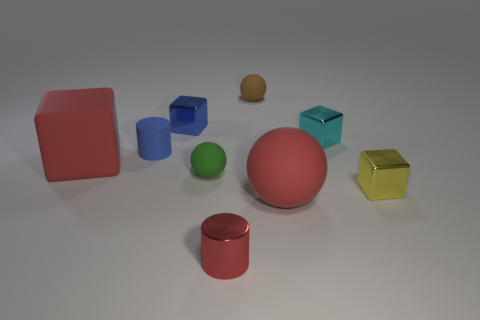Subtract all small blocks. How many blocks are left? 1 Subtract all blue blocks. How many blocks are left? 3 Add 1 tiny green rubber cubes. How many objects exist? 10 Subtract all balls. How many objects are left? 6 Subtract 3 cubes. How many cubes are left? 1 Subtract all brown rubber cylinders. Subtract all small matte cylinders. How many objects are left? 8 Add 8 blue objects. How many blue objects are left? 10 Add 9 large purple blocks. How many large purple blocks exist? 9 Subtract 1 blue cylinders. How many objects are left? 8 Subtract all gray spheres. Subtract all purple blocks. How many spheres are left? 3 